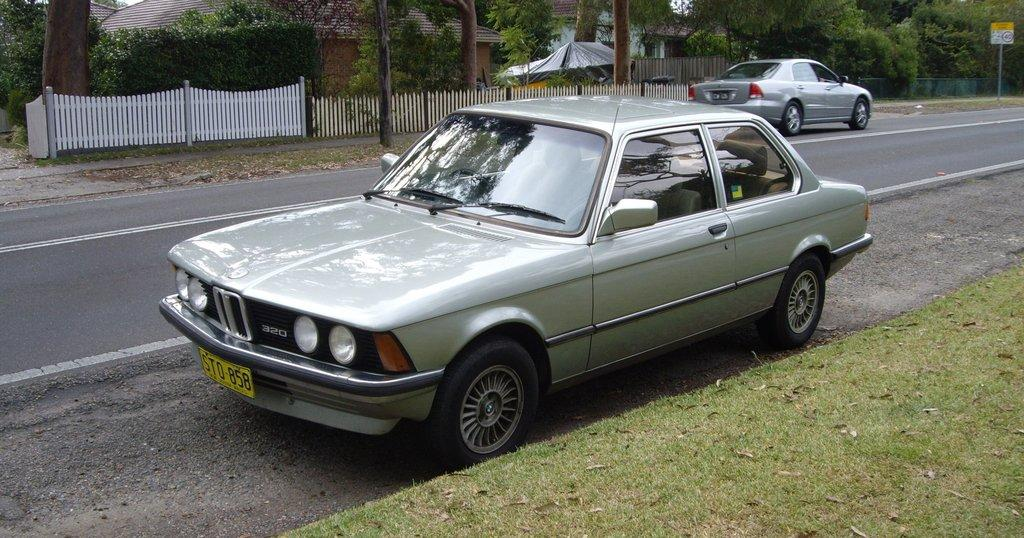What color is the car in the image? The car in the image is white. Where is the car located in the image? The car is parked on the road side. What can be seen behind the car in the image? There is a white gate and fencing behind the car. What is visible in the background of the image? There is a house and trees in the background of the image. What type of fruit is being used to invent a new technology in the image? There is no fruit or invention present in the image; it features a white car parked on the road side with a white gate and fencing behind it, and a house and trees in the background. 